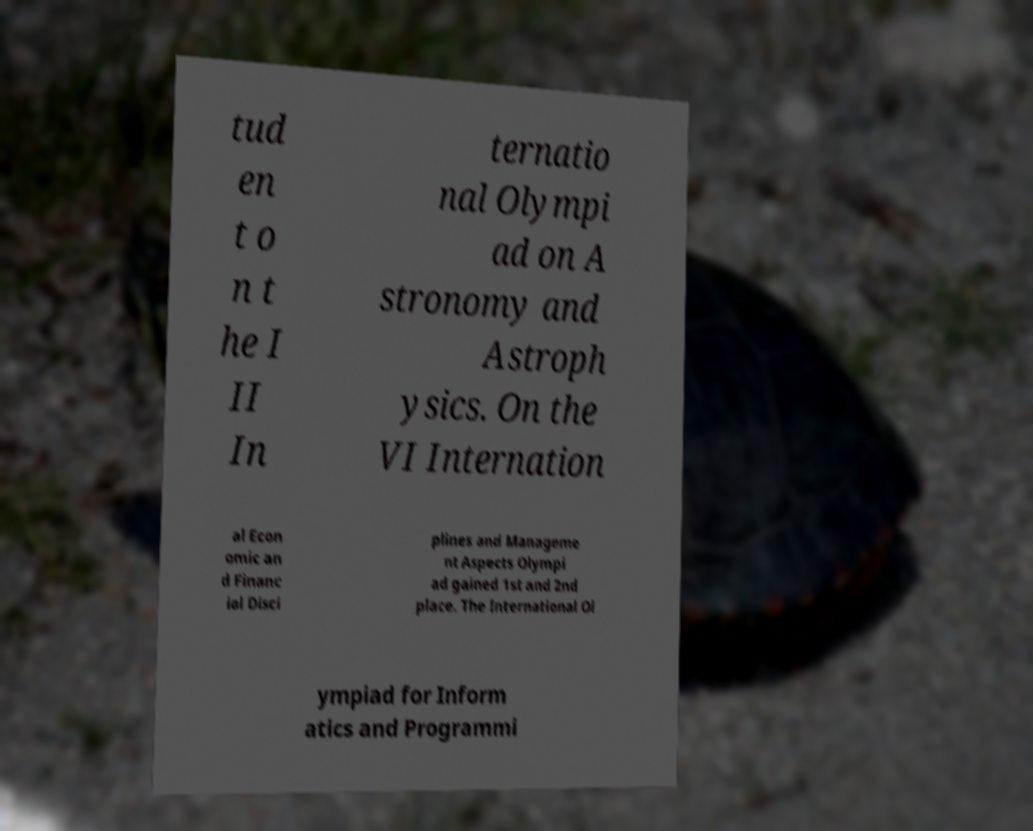What messages or text are displayed in this image? I need them in a readable, typed format. tud en t o n t he I II In ternatio nal Olympi ad on A stronomy and Astroph ysics. On the VI Internation al Econ omic an d Financ ial Disci plines and Manageme nt Aspects Olympi ad gained 1st and 2nd place. The International Ol ympiad for Inform atics and Programmi 